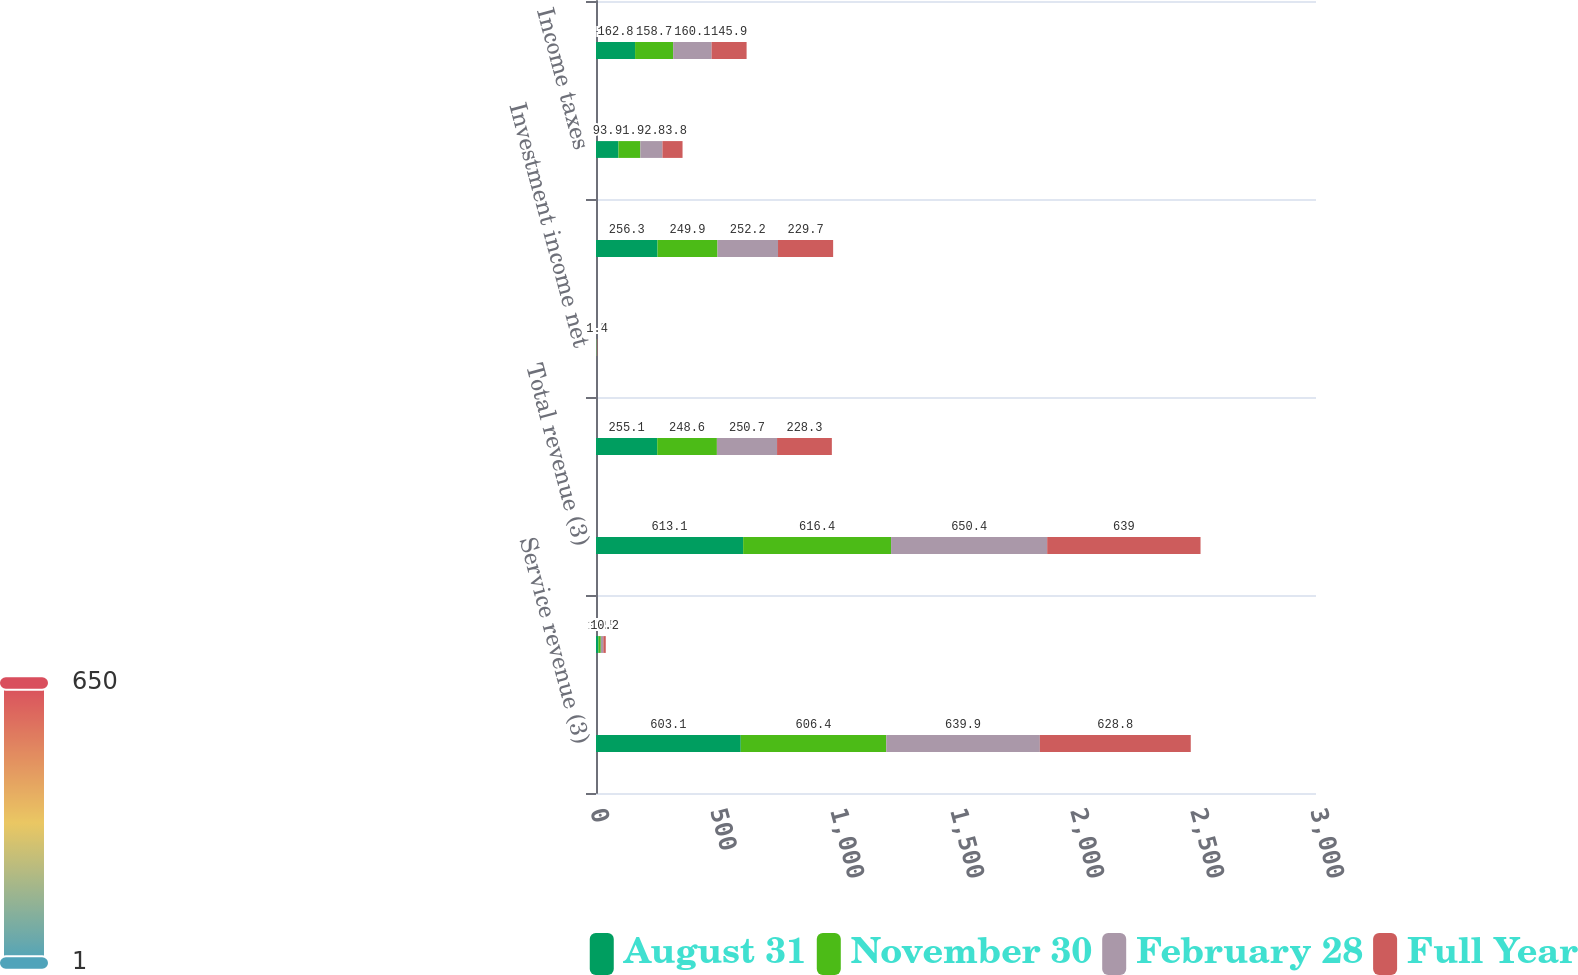<chart> <loc_0><loc_0><loc_500><loc_500><stacked_bar_chart><ecel><fcel>Service revenue (3)<fcel>Interest on funds held for<fcel>Total revenue (3)<fcel>Operating income<fcel>Investment income net<fcel>Income before income taxes<fcel>Income taxes<fcel>Net income<nl><fcel>August 31<fcel>603.1<fcel>10<fcel>613.1<fcel>255.1<fcel>1.2<fcel>256.3<fcel>93.5<fcel>162.8<nl><fcel>November 30<fcel>606.4<fcel>10<fcel>616.4<fcel>248.6<fcel>1.3<fcel>249.9<fcel>91.2<fcel>158.7<nl><fcel>February 28<fcel>639.9<fcel>10.5<fcel>650.4<fcel>250.7<fcel>1.5<fcel>252.2<fcel>92.1<fcel>160.1<nl><fcel>Full Year<fcel>628.8<fcel>10.2<fcel>639<fcel>228.3<fcel>1.4<fcel>229.7<fcel>83.8<fcel>145.9<nl></chart> 